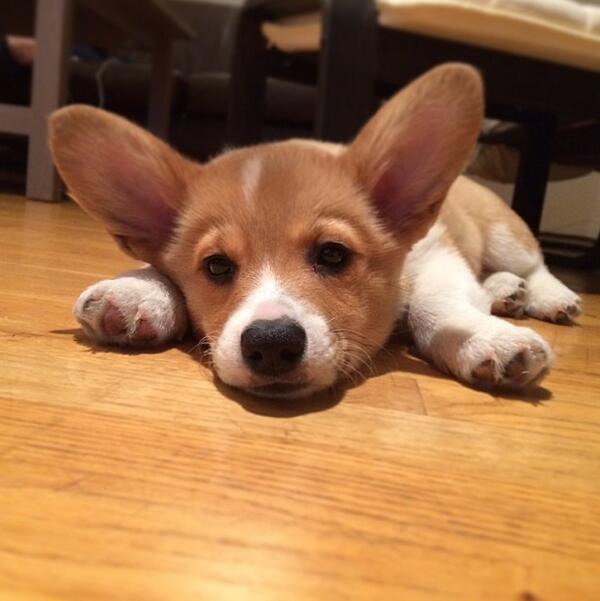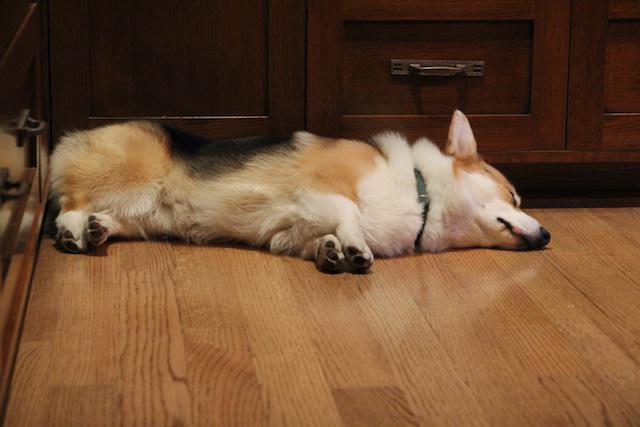The first image is the image on the left, the second image is the image on the right. Evaluate the accuracy of this statement regarding the images: "All corgis are reclining on wood floors, and at least one corgi has its eyes shut.". Is it true? Answer yes or no. Yes. The first image is the image on the left, the second image is the image on the right. Assess this claim about the two images: "The left image contains a dog that is laying down inside on a wooden floor.". Correct or not? Answer yes or no. Yes. 